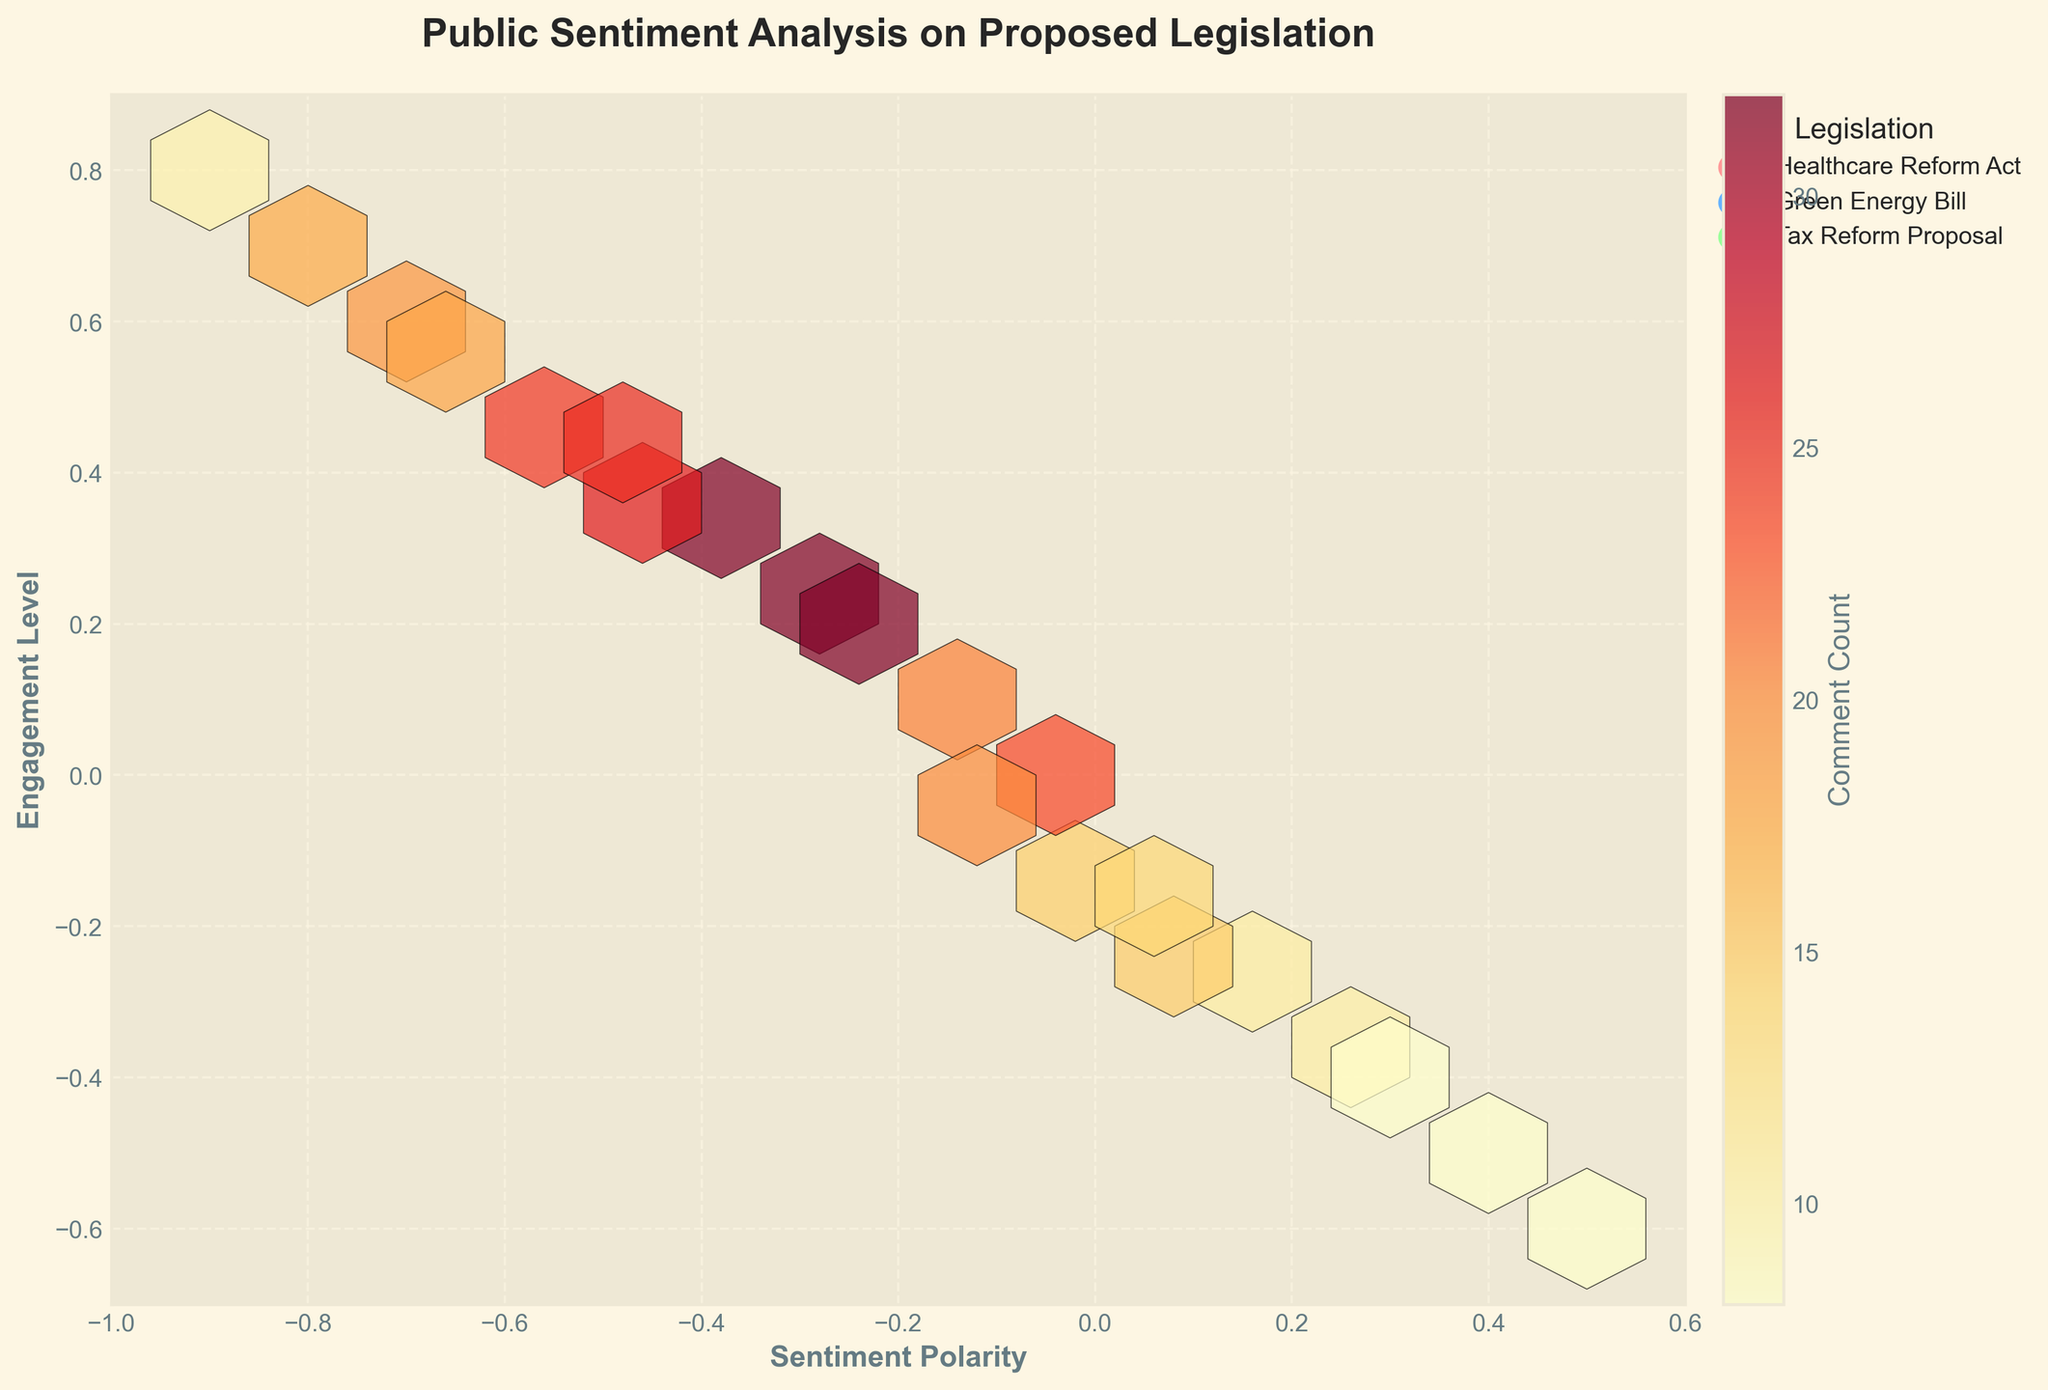What is the title of the figure? The title of the figure is displayed prominently at the top.
Answer: Public Sentiment Analysis on Proposed Legislation Which axis represents sentiment polarity? The sentiment polarity is labeled on the horizontal axis.
Answer: The x-axis What color represents the 'Healthcare Reform Act'? Each legislation is represented by a specific color in the legend. The 'Healthcare Reform Act' is represented by a red color.
Answer: Red Which legislation has the highest comment count at a positive sentiment polarity and high engagement level? By looking at the top-left area of the plot (positive sentiment polarity and high engagement level) and the color codes, we can see that the highest hexbin count is associated with the 'Healthcare Reform Act'.
Answer: Healthcare Reform Act What range of sentiment polarity values are displayed on the x-axis? The x-axis limits can be observed by looking at the horizontal range of the plot. It's from -1 to 0.6.
Answer: -1 to 0.6 Among the policies, which one has the most significant point of negative sentiment polarity but higher engagement compared to others? By comparing the colors and sentiment polarities, the 'Healthcare Reform Act' shows the most significant count on negative sentiment polarity with slightly higher engagement.
Answer: Healthcare Reform Act Besides the color representing the 'Healthcare Reform Act', which other legislation has a significant presence in the same area (high engagement and positive polarity)? By comparing the high engagement areas with multiple significant points, the 'Green Energy Bill' also has notable presence.
Answer: Green Energy Bill Which proposed legislation appears to have a moderate engagement level with a neutral sentiment polarity? By noting moderate engagement levels around neutral sentiment (near 0,0), the 'Green Energy Bill' is observed in that region with noticeable counts.
Answer: Green Energy Bill What is the color of the hexagons indicating the highest comment count? The color bar legends help interpret the color scale, where the highest counts use the darkest red color.
Answer: Darkest red 